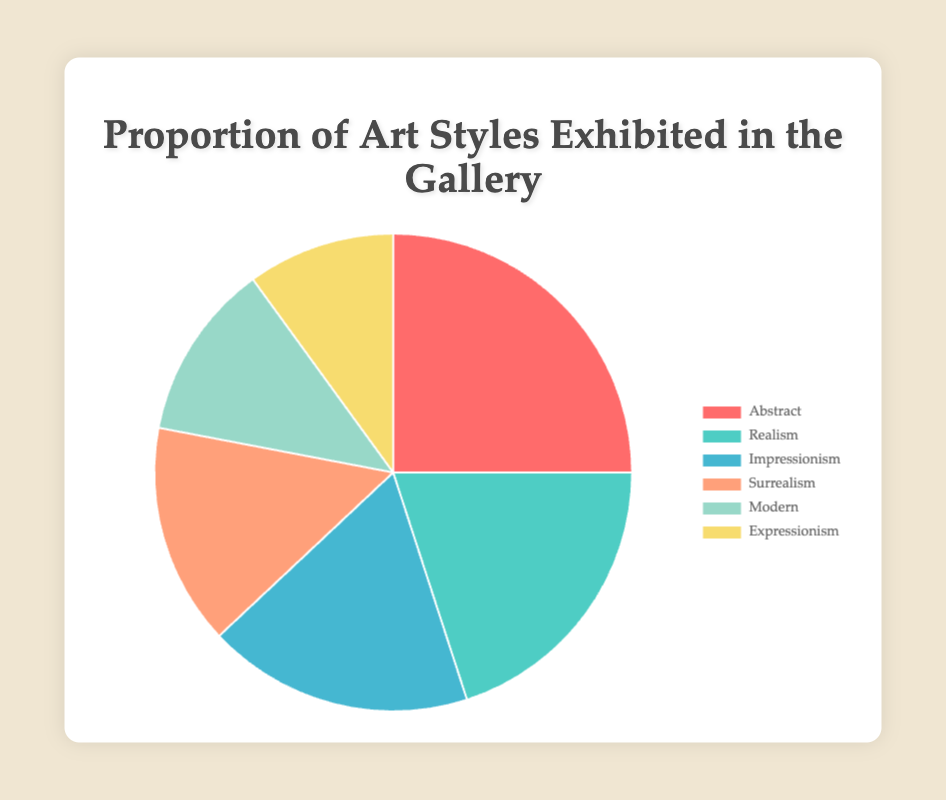What art style has the largest proportion in the exhibition? The largest proportion can be identified by looking at the biggest segment in the pie chart. The largest segment corresponds to 'Abstract'.
Answer: Abstract What is the total proportion of Impressionism and Surrealism combined? The combined proportion is found by adding the proportions of 'Impressionism' and 'Surrealism'. 18% + 15% = 33%
Answer: 33% Which art style has a smaller proportion: Modern or Expressionism? By comparing the proportions directly, 'Modern' has 12% while 'Expressionism' has 10%. Hence, 'Expressionism' has the smaller proportion.
Answer: Expressionism Are there more works of Realism or Surrealism in the gallery? The pie chart shows Realism with a proportion of 20% and Surrealism with 15%. Therefore, Realism has a higher proportion than Surrealism.
Answer: Realism What is the difference in proportion between the largest and the smallest exhibited art style? The largest proportion is 'Abstract' with 25% and the smallest is 'Expressionism' with 10%. The difference is 25% - 10% = 15%.
Answer: 15% What is the median proportion of all the art styles exhibited? To find the median, list the proportions in order: 10%, 12%, 15%, 18%, 20%, 25%. The middle values are 15% and 18%, so the median is the average: (15 + 18)/2 = 16.5%.
Answer: 16.5% Which style has a higher proportion: Impressionism or Modern? According to the pie chart, Impressionism has 18% and Modern has 12%. Therefore, Impressionism has a higher proportion.
Answer: Impressionism What is the proportion of art styles excluding Abstract and Realism? To find this, subtract the proportions of Abstract (25%) and Realism (20%) from the total 100%. The remainder is 100% - 25% - 20% = 55%.
Answer: 55% Is the proportion of Modern art greater than or equal to half of the proportion of Abstract? The proportion of Modern is 12% and half the proportion of Abstract is 25%/2 = 12.5%. Since 12% < 12.5%, Modern is not greater than or equal to half the proportion of Abstract.
Answer: No What proportion of the exhibited art styles are either Abstract or Realism? The proportion is found by adding the proportions of 'Abstract' and 'Realism'. 25% + 20% = 45%.
Answer: 45% 